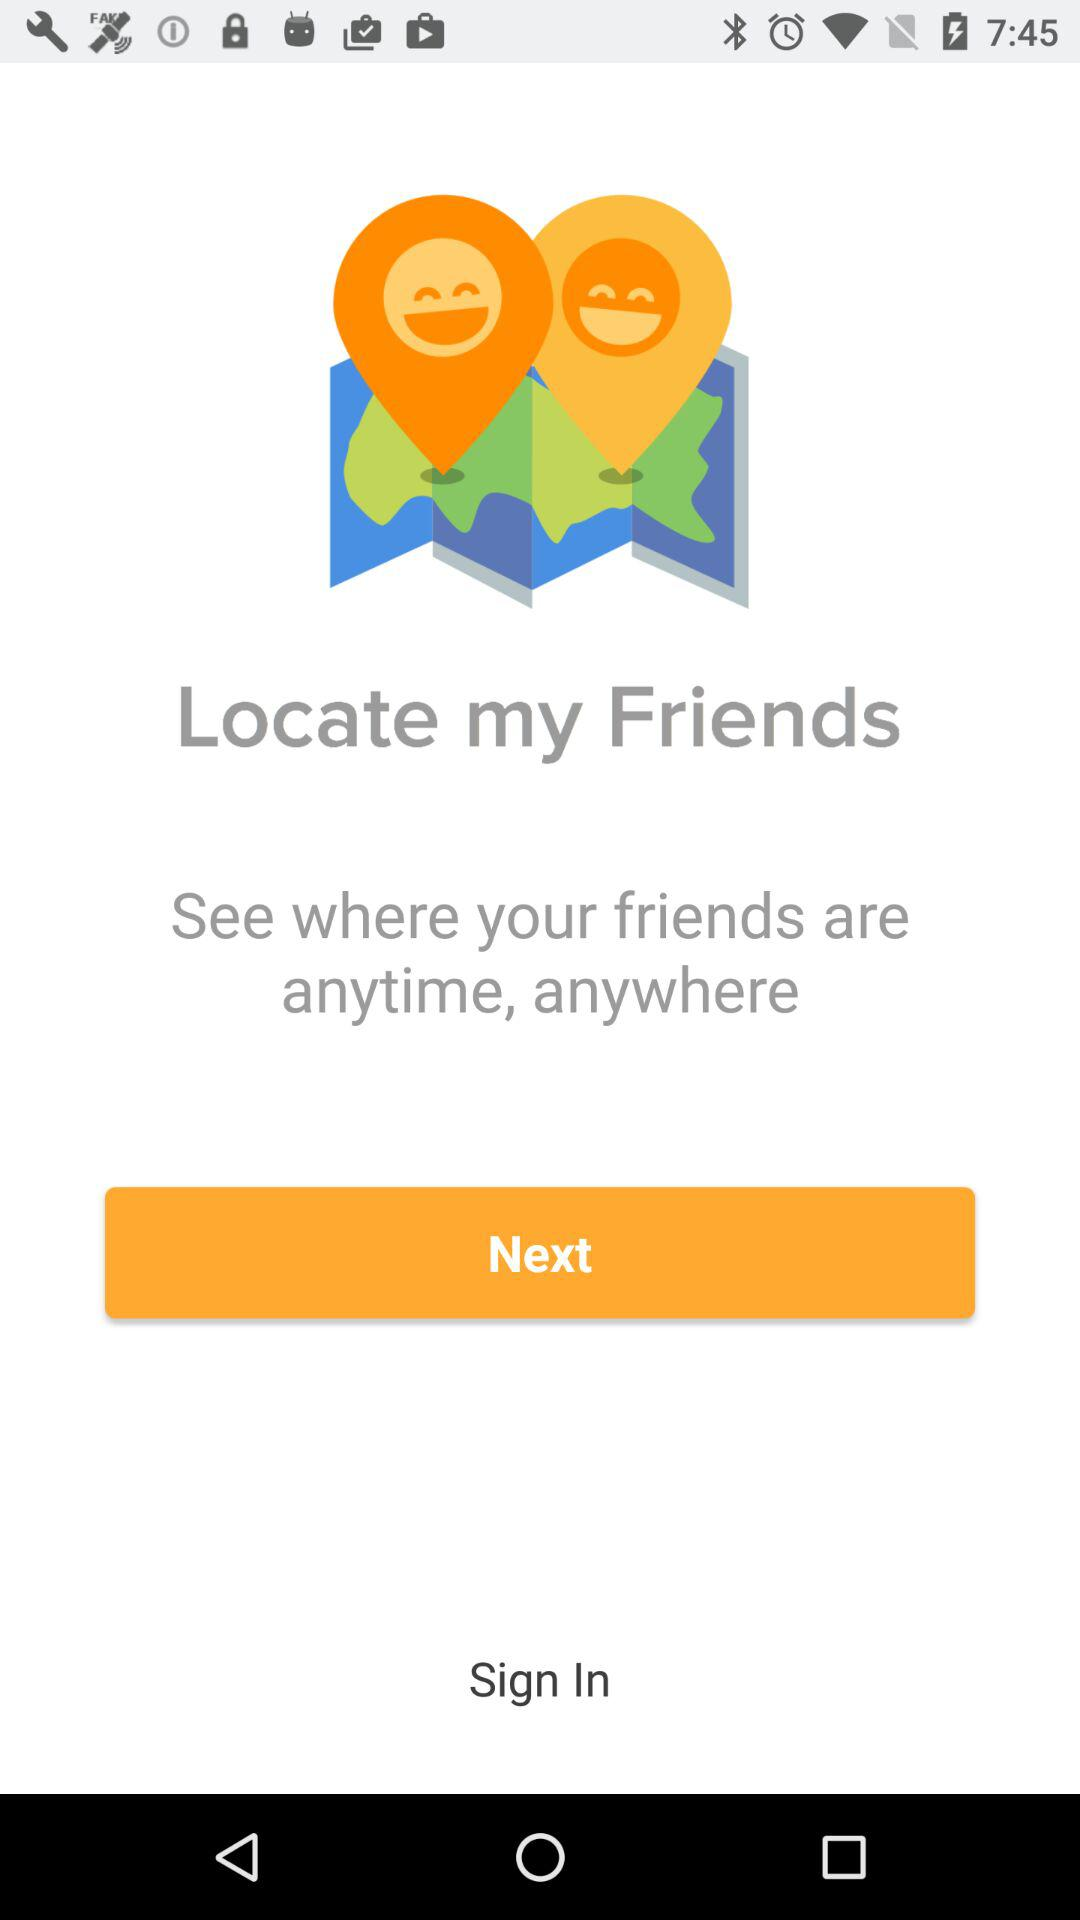What is the application name? The application name is "Locate my Friends". 